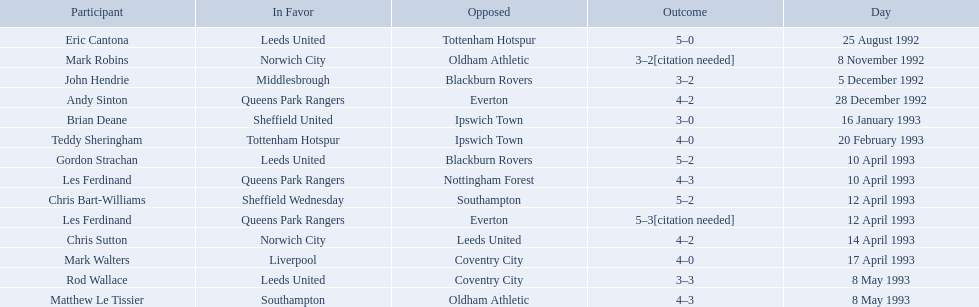What are the results? 5–0, 3–2[citation needed], 3–2, 4–2, 3–0, 4–0, 5–2, 4–3, 5–2, 5–3[citation needed], 4–2, 4–0, 3–3, 4–3. What result did mark robins have? 3–2[citation needed]. What other player had that result? John Hendrie. 